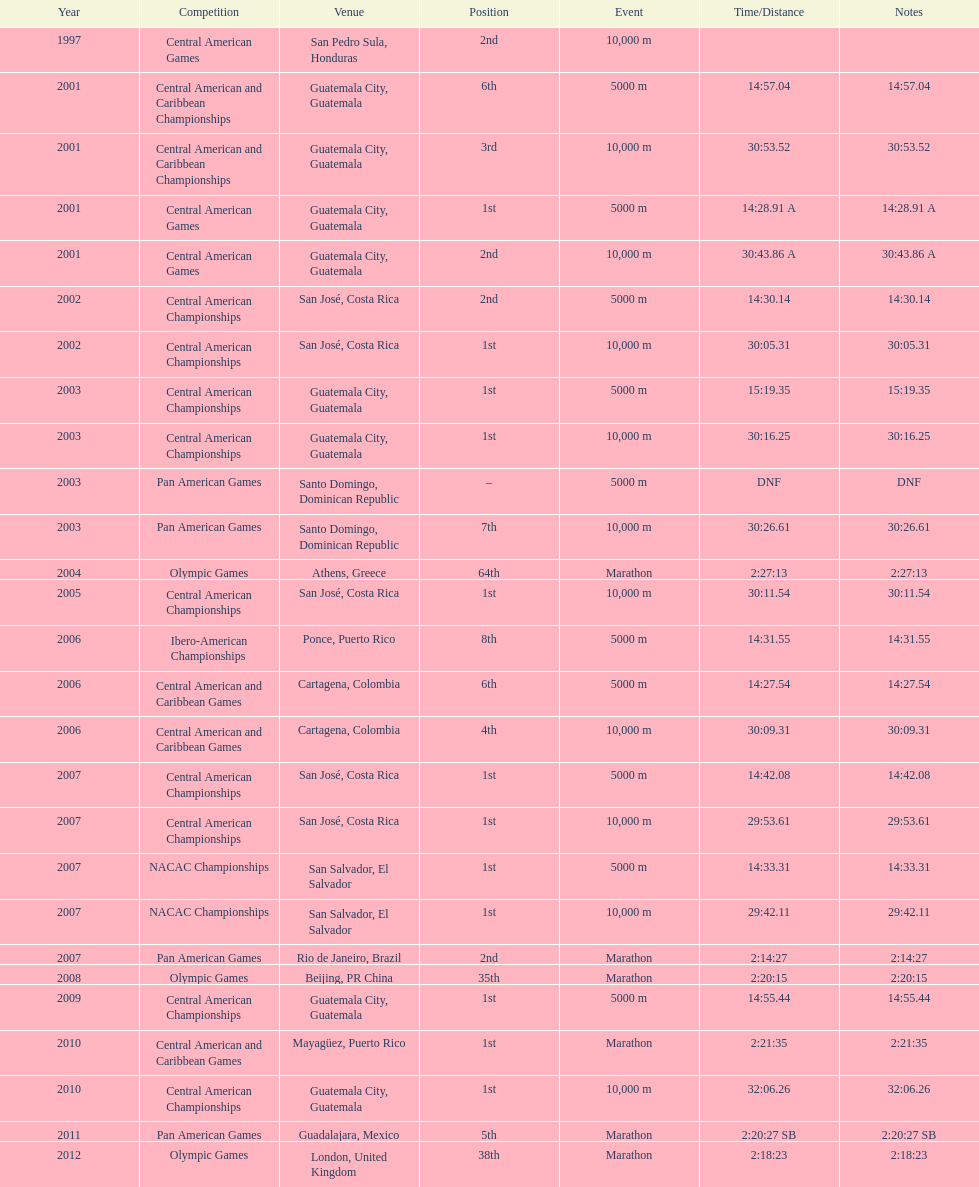The central american championships and what other competition occurred in 2010? Central American and Caribbean Games. 